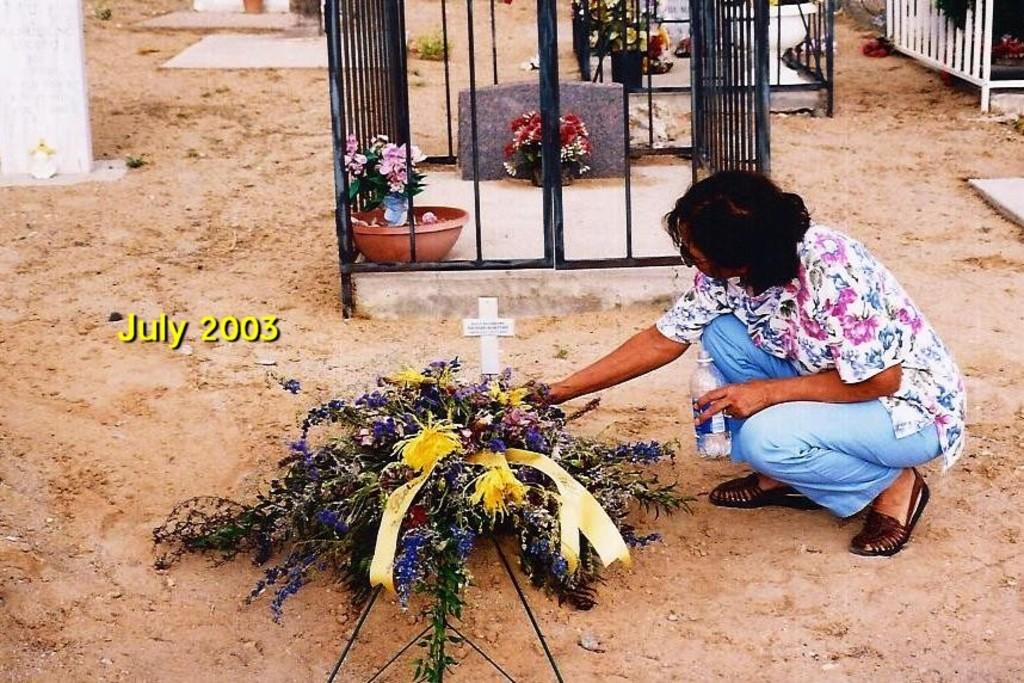Who is present in the image? There is a woman in the image. What is the woman wearing? The woman is wearing clothes. What is the woman holding in her hand? The woman is holding a bottle in her hand. What can be seen in the background of the image? There are flower pots and a fence in the image. What is the nature of the watermark in the image? There is a watermark in the image. What type of surface is visible in the image? There is sand visible in the image. What type of game is the woman playing in the image? There is no game being played in the image; the woman is holding a bottle and standing near flower pots and a fence. What is the woman wearing on her hands to keep them warm? The woman is not wearing any mittens in the image; she is simply holding a bottle. 